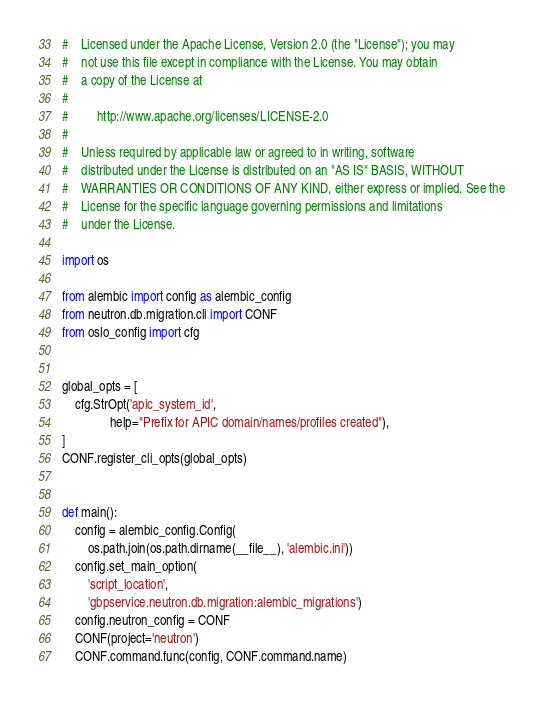Convert code to text. <code><loc_0><loc_0><loc_500><loc_500><_Python_>#    Licensed under the Apache License, Version 2.0 (the "License"); you may
#    not use this file except in compliance with the License. You may obtain
#    a copy of the License at
#
#         http://www.apache.org/licenses/LICENSE-2.0
#
#    Unless required by applicable law or agreed to in writing, software
#    distributed under the License is distributed on an "AS IS" BASIS, WITHOUT
#    WARRANTIES OR CONDITIONS OF ANY KIND, either express or implied. See the
#    License for the specific language governing permissions and limitations
#    under the License.

import os

from alembic import config as alembic_config
from neutron.db.migration.cli import CONF
from oslo_config import cfg


global_opts = [
    cfg.StrOpt('apic_system_id',
               help="Prefix for APIC domain/names/profiles created"),
]
CONF.register_cli_opts(global_opts)


def main():
    config = alembic_config.Config(
        os.path.join(os.path.dirname(__file__), 'alembic.ini'))
    config.set_main_option(
        'script_location',
        'gbpservice.neutron.db.migration:alembic_migrations')
    config.neutron_config = CONF
    CONF(project='neutron')
    CONF.command.func(config, CONF.command.name)
</code> 